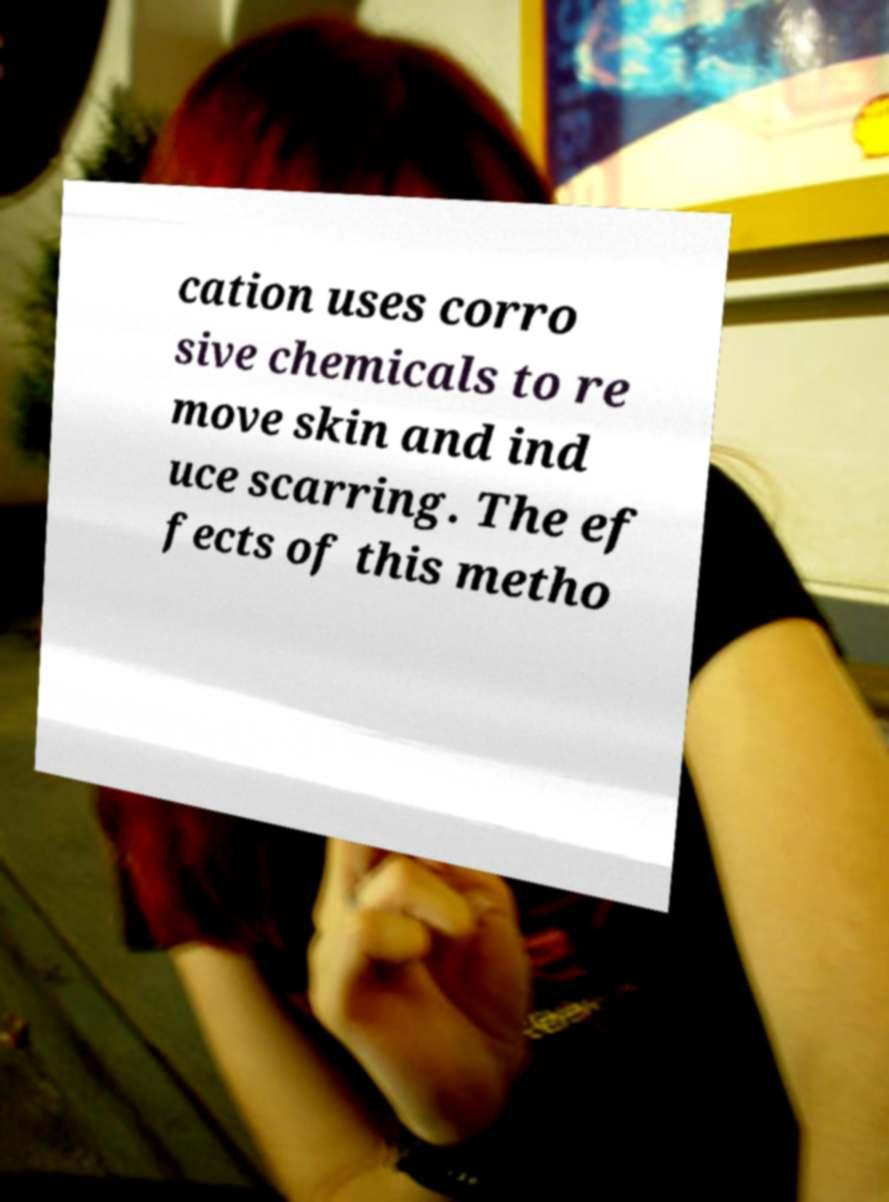Please read and relay the text visible in this image. What does it say? cation uses corro sive chemicals to re move skin and ind uce scarring. The ef fects of this metho 